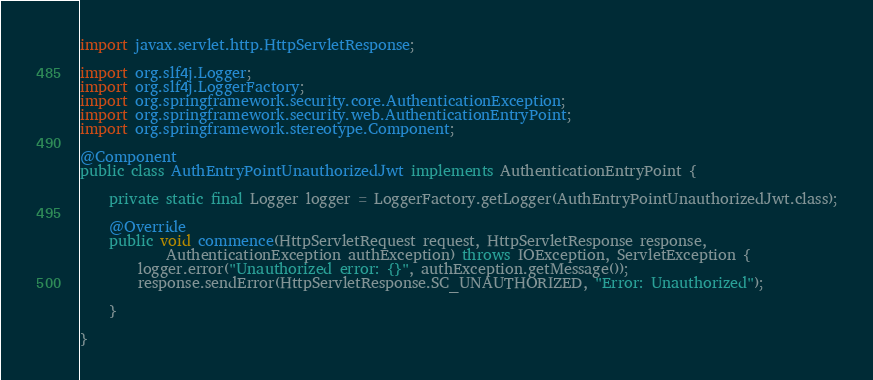<code> <loc_0><loc_0><loc_500><loc_500><_Java_>import javax.servlet.http.HttpServletResponse;

import org.slf4j.Logger;
import org.slf4j.LoggerFactory;
import org.springframework.security.core.AuthenticationException;
import org.springframework.security.web.AuthenticationEntryPoint;
import org.springframework.stereotype.Component;

@Component
public class AuthEntryPointUnauthorizedJwt implements AuthenticationEntryPoint {
	
	private static final Logger logger = LoggerFactory.getLogger(AuthEntryPointUnauthorizedJwt.class);

	@Override
	public void commence(HttpServletRequest request, HttpServletResponse response,
			AuthenticationException authException) throws IOException, ServletException {
		logger.error("Unauthorized error: {}", authException.getMessage());
		response.sendError(HttpServletResponse.SC_UNAUTHORIZED, "Error: Unauthorized");

	}

}
</code> 